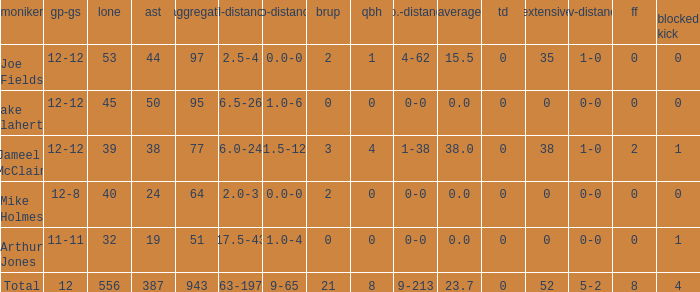How many tackle assists for the player who averages 23.7? 387.0. I'm looking to parse the entire table for insights. Could you assist me with that? {'header': ['moniker', 'gp-gs', 'lone', 'ast', 'aggregate', 'tfl-distance', 'no-distance', 'brup', 'qbh', 'no.-distance', 'average', 'td', 'extensive', 'rcv-distance', 'ff', 'blocked kick'], 'rows': [['Joe Fields', '12-12', '53', '44', '97', '2.5-4', '0.0-0', '2', '1', '4-62', '15.5', '0', '35', '1-0', '0', '0'], ['Jake Flaherty', '12-12', '45', '50', '95', '6.5-26', '1.0-6', '0', '0', '0-0', '0.0', '0', '0', '0-0', '0', '0'], ['Jameel McClain', '12-12', '39', '38', '77', '6.0-24', '1.5-12', '3', '4', '1-38', '38.0', '0', '38', '1-0', '2', '1'], ['Mike Holmes', '12-8', '40', '24', '64', '2.0-3', '0.0-0', '2', '0', '0-0', '0.0', '0', '0', '0-0', '0', '0'], ['Arthur Jones', '11-11', '32', '19', '51', '17.5-43', '1.0-4', '0', '0', '0-0', '0.0', '0', '0', '0-0', '0', '1'], ['Total', '12', '556', '387', '943', '63-197', '9-65', '21', '8', '9-213', '23.7', '0', '52', '5-2', '8', '4']]} 